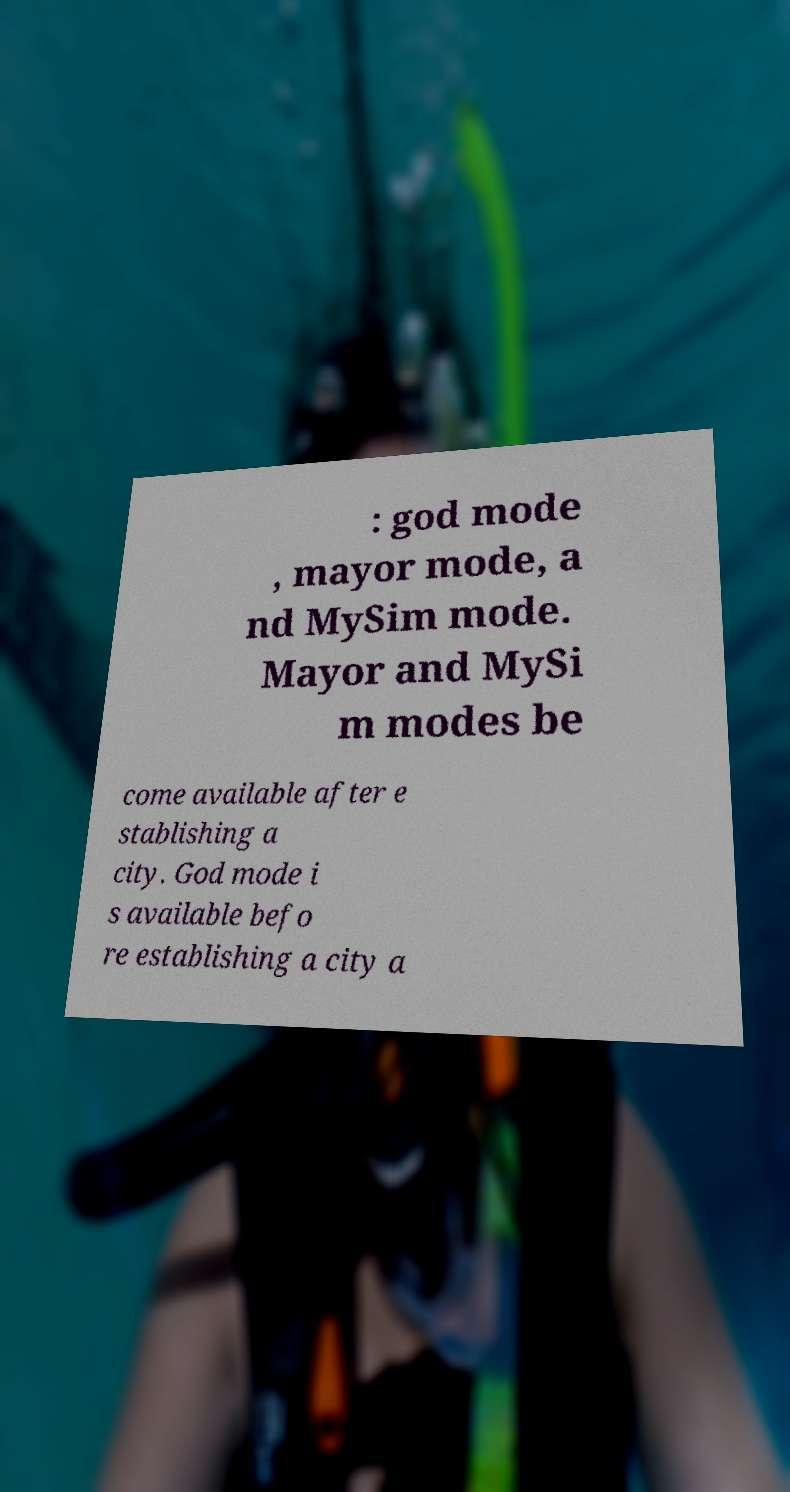There's text embedded in this image that I need extracted. Can you transcribe it verbatim? : god mode , mayor mode, a nd MySim mode. Mayor and MySi m modes be come available after e stablishing a city. God mode i s available befo re establishing a city a 